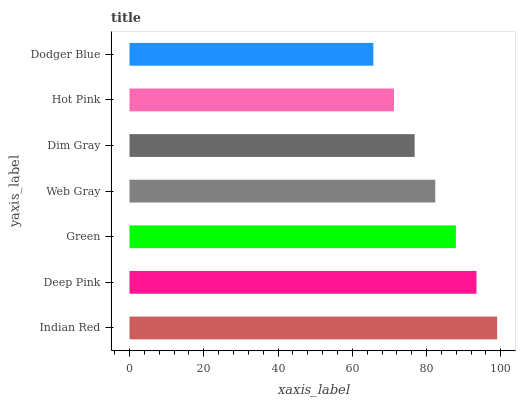Is Dodger Blue the minimum?
Answer yes or no. Yes. Is Indian Red the maximum?
Answer yes or no. Yes. Is Deep Pink the minimum?
Answer yes or no. No. Is Deep Pink the maximum?
Answer yes or no. No. Is Indian Red greater than Deep Pink?
Answer yes or no. Yes. Is Deep Pink less than Indian Red?
Answer yes or no. Yes. Is Deep Pink greater than Indian Red?
Answer yes or no. No. Is Indian Red less than Deep Pink?
Answer yes or no. No. Is Web Gray the high median?
Answer yes or no. Yes. Is Web Gray the low median?
Answer yes or no. Yes. Is Dim Gray the high median?
Answer yes or no. No. Is Deep Pink the low median?
Answer yes or no. No. 